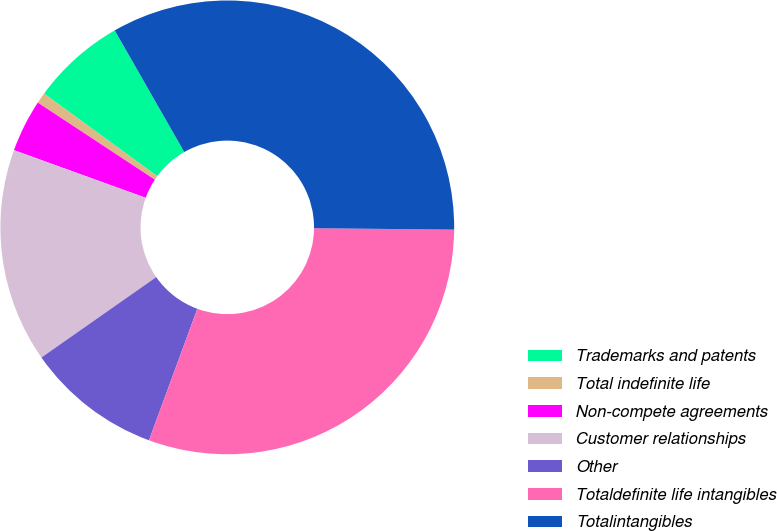Convert chart. <chart><loc_0><loc_0><loc_500><loc_500><pie_chart><fcel>Trademarks and patents<fcel>Total indefinite life<fcel>Non-compete agreements<fcel>Customer relationships<fcel>Other<fcel>Totaldefinite life intangibles<fcel>Totalintangibles<nl><fcel>6.7%<fcel>0.77%<fcel>3.74%<fcel>15.25%<fcel>9.67%<fcel>30.45%<fcel>33.42%<nl></chart> 